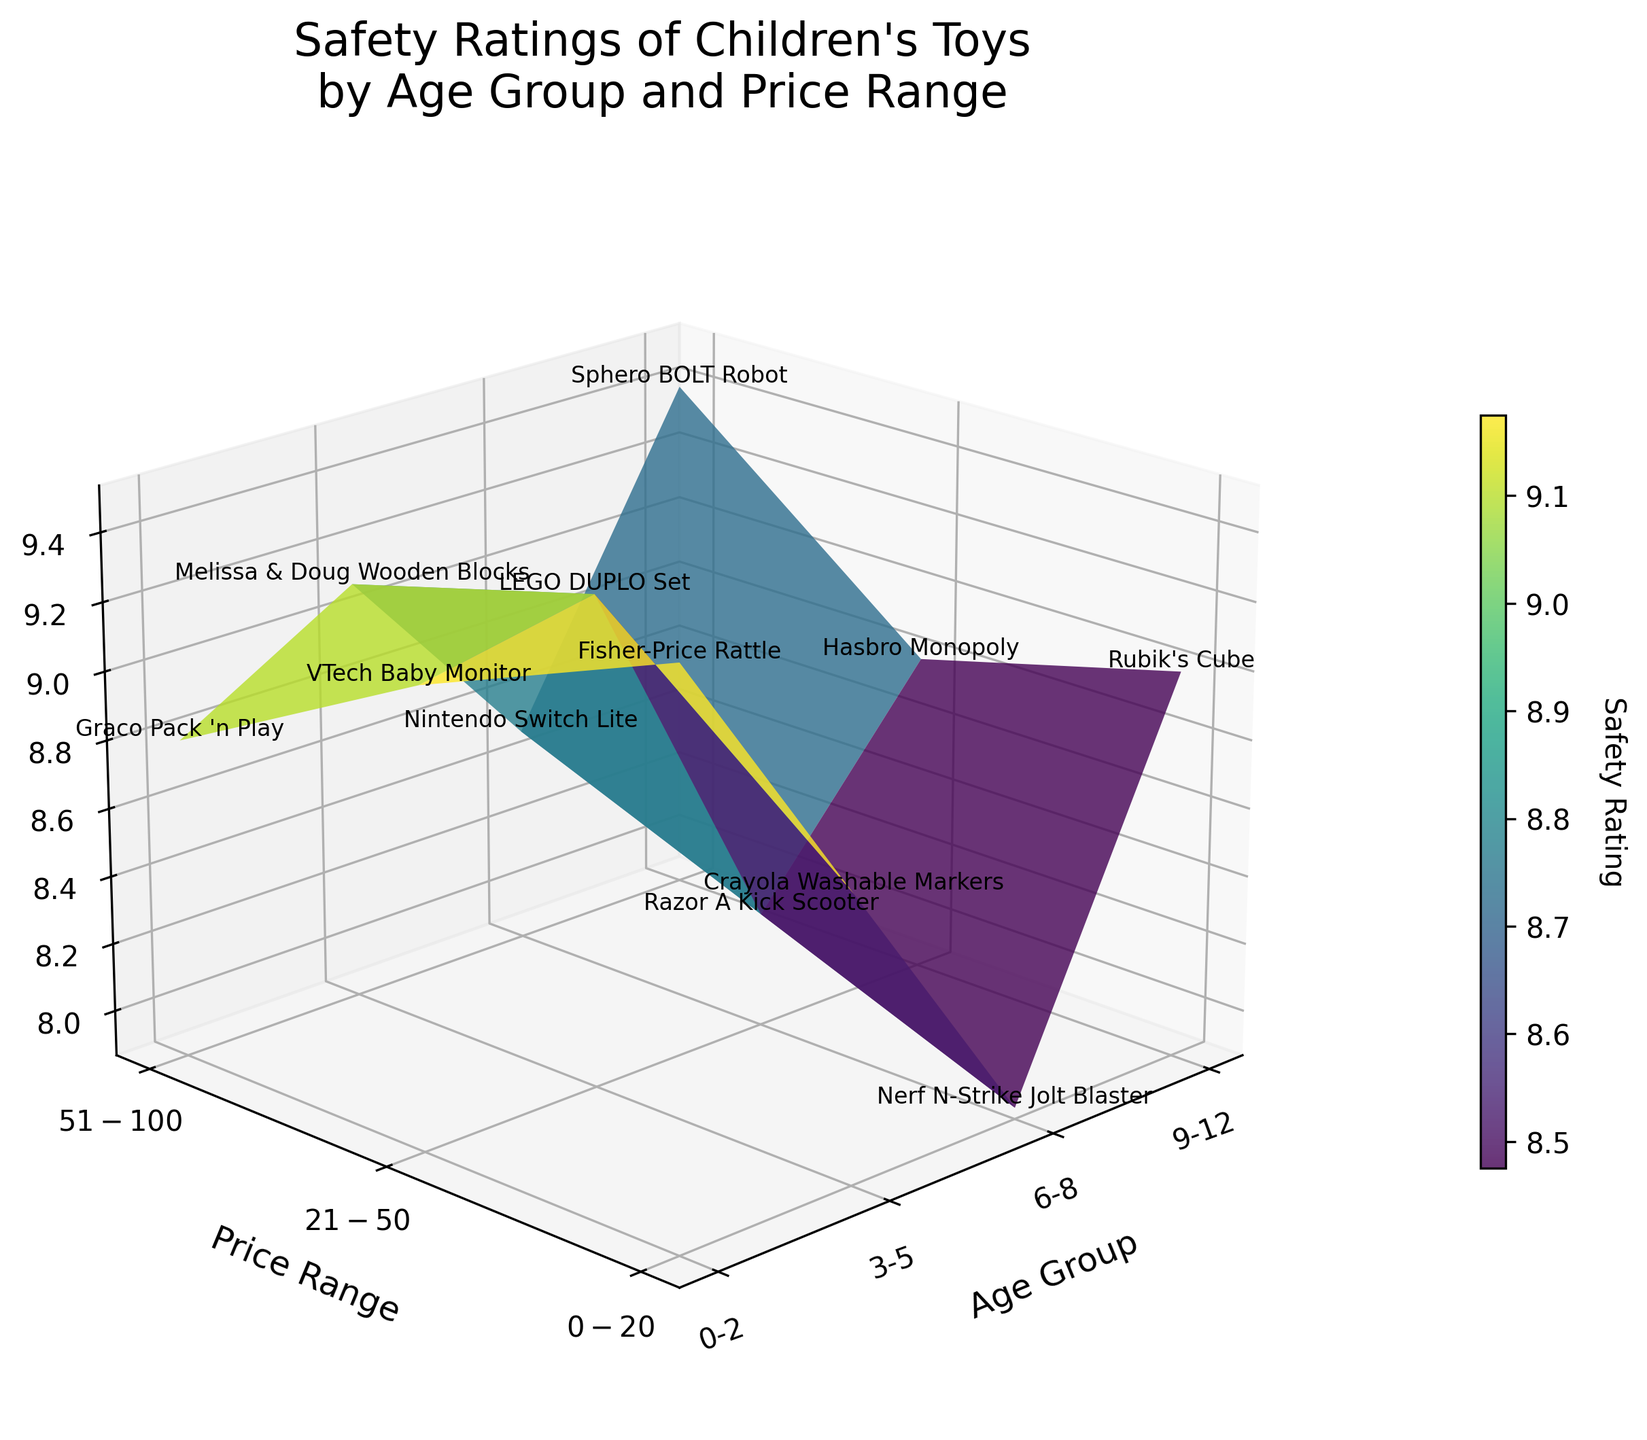What are the age groups represented in the plot? The x-axis displays various age groups. These are labels on that axis.
Answer: 0-2, 3-5, 6-8, 9-12 Which toy has the highest safety rating in the 9-12 age group? Looking along the x-axis for 9-12 and identifying the tallest z-axis value, and then reading the toy name next to that value.
Answer: Sphero BOLT Robot What is the title of the 3D plot? The title is positioned at the top of the plot.
Answer: Safety Ratings of Children's Toys by Age Group and Price Range Which price range generally has the highest safety ratings across all age groups? Observing the z-axis values along each row of the y-axis (price ranges) and seeing which has the tallest bars on average.
Answer: $21-$50 Which age group has the lowest safety rating for any toy? Finding the shortest bar along the z-axis and noting its corresponding x-axis (age group).
Answer: 6-8 Which toy has the highest safety rating in the $21-$50 price range? Looking along the y-axis for the $21-$50 price range and identifying the highest z-axis value, then reading the toy name next to that value.
Answer: LEGO DUPLO Set How does the safety rating of the Nintendo Switch Lite compare with the Graco Pack 'n Play? Finding the z-axis values for the Nintendo Switch Lite in 6-8 age and $51-$100 price, and for Graco in 0-2 age and $51-$100 price, then comparing them.
Answer: Nintendo Switch Lite is higher What colors are used to show the safety ratings on the surface plot? Observing the variation in colors representing different values on the surface.
Answer: Gradient from green to blue Which toy in the 3-5 age group has the highest safety rating? Looking along the x-axis for 3-5 and identifying the tallest z-axis value, then reading the toy name next to that value.
Answer: LEGO DUPLO Set What is the general trend of safety ratings as the price range increases within each age group? Observing the z-axis values from the lowest to the highest price ranges for each age group to identify any patterns.
Answer: Generally increases 